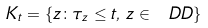<formula> <loc_0><loc_0><loc_500><loc_500>K _ { t } = \{ z \colon \tau _ { z } \leq t , \, z \in \ D D \}</formula> 